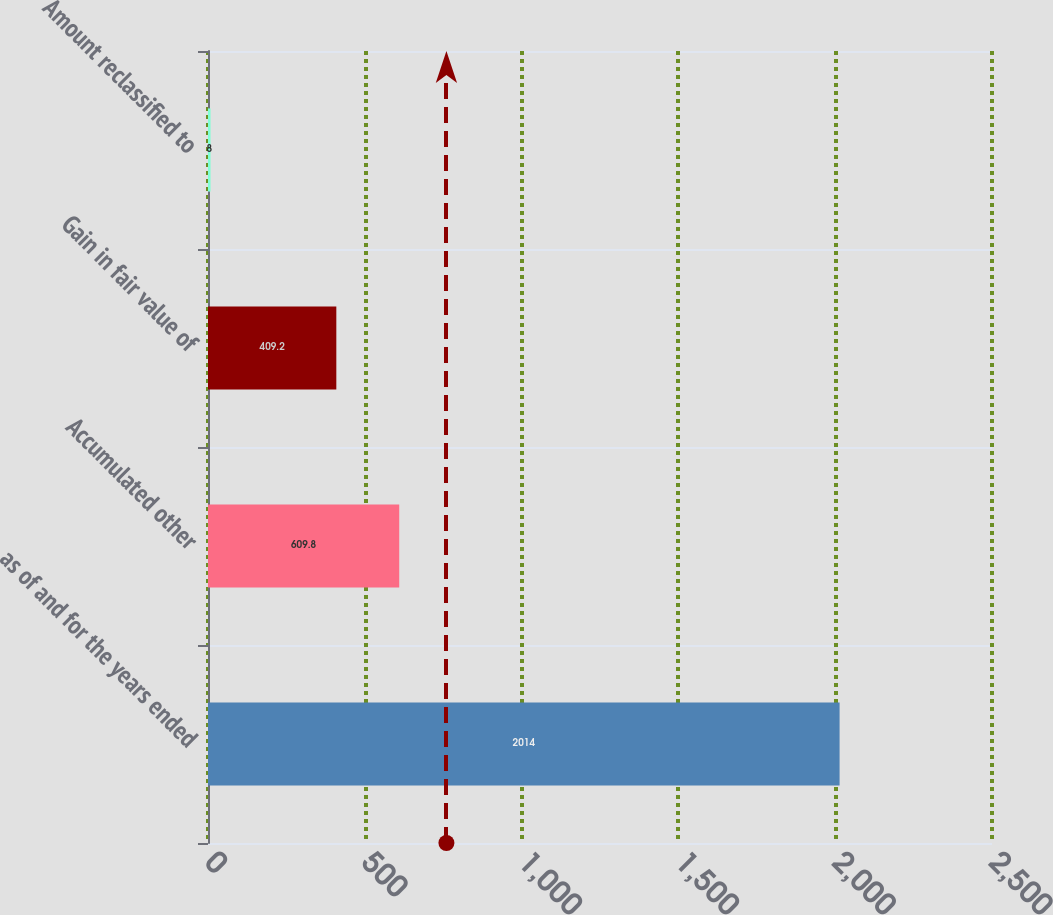<chart> <loc_0><loc_0><loc_500><loc_500><bar_chart><fcel>as of and for the years ended<fcel>Accumulated other<fcel>Gain in fair value of<fcel>Amount reclassified to<nl><fcel>2014<fcel>609.8<fcel>409.2<fcel>8<nl></chart> 